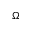<formula> <loc_0><loc_0><loc_500><loc_500>\Omega</formula> 